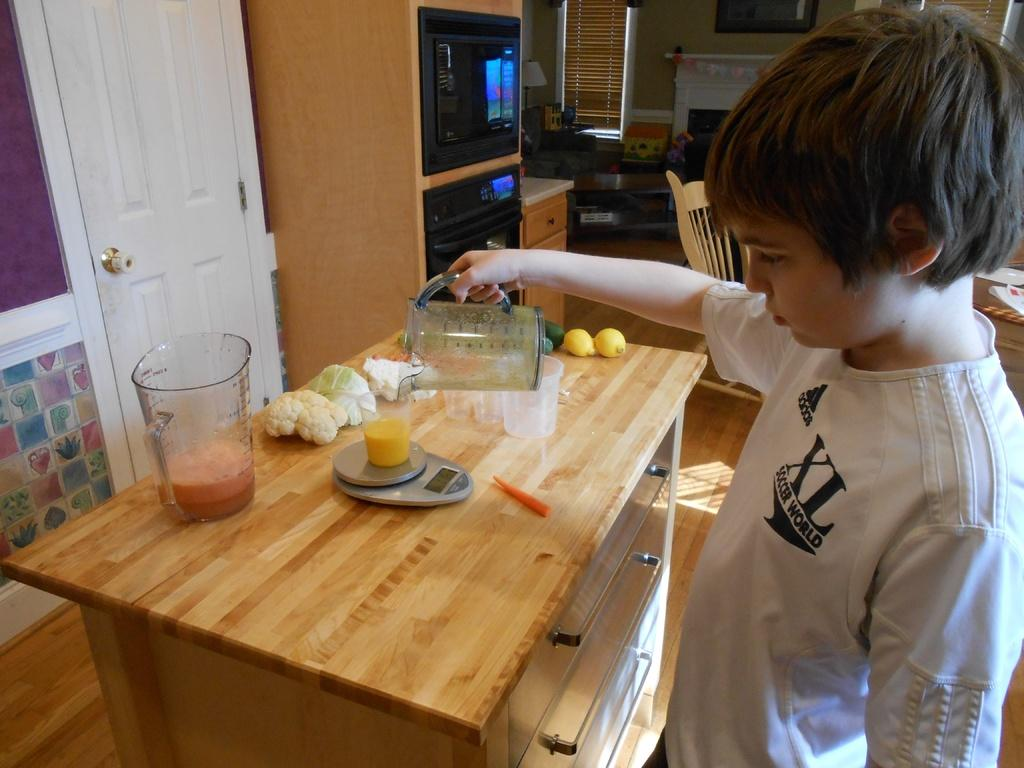<image>
Write a terse but informative summary of the picture. A boy wearing an XL Soccer World shirt pours a glass of orange juice 